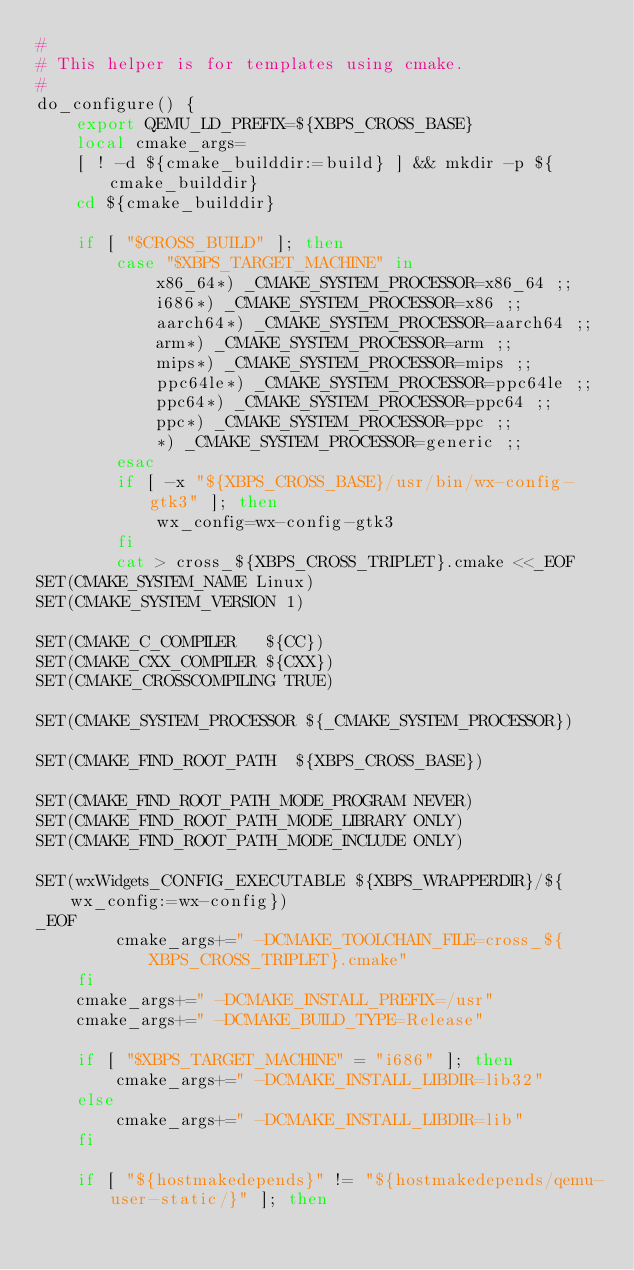<code> <loc_0><loc_0><loc_500><loc_500><_Bash_>#
# This helper is for templates using cmake.
#
do_configure() {
	export QEMU_LD_PREFIX=${XBPS_CROSS_BASE}
	local cmake_args=
	[ ! -d ${cmake_builddir:=build} ] && mkdir -p ${cmake_builddir}
	cd ${cmake_builddir}

	if [ "$CROSS_BUILD" ]; then
		case "$XBPS_TARGET_MACHINE" in
			x86_64*) _CMAKE_SYSTEM_PROCESSOR=x86_64 ;;
			i686*) _CMAKE_SYSTEM_PROCESSOR=x86 ;;
			aarch64*) _CMAKE_SYSTEM_PROCESSOR=aarch64 ;;
			arm*) _CMAKE_SYSTEM_PROCESSOR=arm ;;
			mips*) _CMAKE_SYSTEM_PROCESSOR=mips ;;
			ppc64le*) _CMAKE_SYSTEM_PROCESSOR=ppc64le ;;
			ppc64*) _CMAKE_SYSTEM_PROCESSOR=ppc64 ;;
			ppc*) _CMAKE_SYSTEM_PROCESSOR=ppc ;;
			*) _CMAKE_SYSTEM_PROCESSOR=generic ;;
		esac
		if [ -x "${XBPS_CROSS_BASE}/usr/bin/wx-config-gtk3" ]; then
			wx_config=wx-config-gtk3
		fi
		cat > cross_${XBPS_CROSS_TRIPLET}.cmake <<_EOF
SET(CMAKE_SYSTEM_NAME Linux)
SET(CMAKE_SYSTEM_VERSION 1)

SET(CMAKE_C_COMPILER   ${CC})
SET(CMAKE_CXX_COMPILER ${CXX})
SET(CMAKE_CROSSCOMPILING TRUE)

SET(CMAKE_SYSTEM_PROCESSOR ${_CMAKE_SYSTEM_PROCESSOR})

SET(CMAKE_FIND_ROOT_PATH  ${XBPS_CROSS_BASE})

SET(CMAKE_FIND_ROOT_PATH_MODE_PROGRAM NEVER)
SET(CMAKE_FIND_ROOT_PATH_MODE_LIBRARY ONLY)
SET(CMAKE_FIND_ROOT_PATH_MODE_INCLUDE ONLY)

SET(wxWidgets_CONFIG_EXECUTABLE ${XBPS_WRAPPERDIR}/${wx_config:=wx-config})
_EOF
		cmake_args+=" -DCMAKE_TOOLCHAIN_FILE=cross_${XBPS_CROSS_TRIPLET}.cmake"
	fi
	cmake_args+=" -DCMAKE_INSTALL_PREFIX=/usr"
	cmake_args+=" -DCMAKE_BUILD_TYPE=Release"

	if [ "$XBPS_TARGET_MACHINE" = "i686" ]; then
		cmake_args+=" -DCMAKE_INSTALL_LIBDIR=lib32"
	else
		cmake_args+=" -DCMAKE_INSTALL_LIBDIR=lib"
	fi

	if [ "${hostmakedepends}" != "${hostmakedepends/qemu-user-static/}" ]; then</code> 